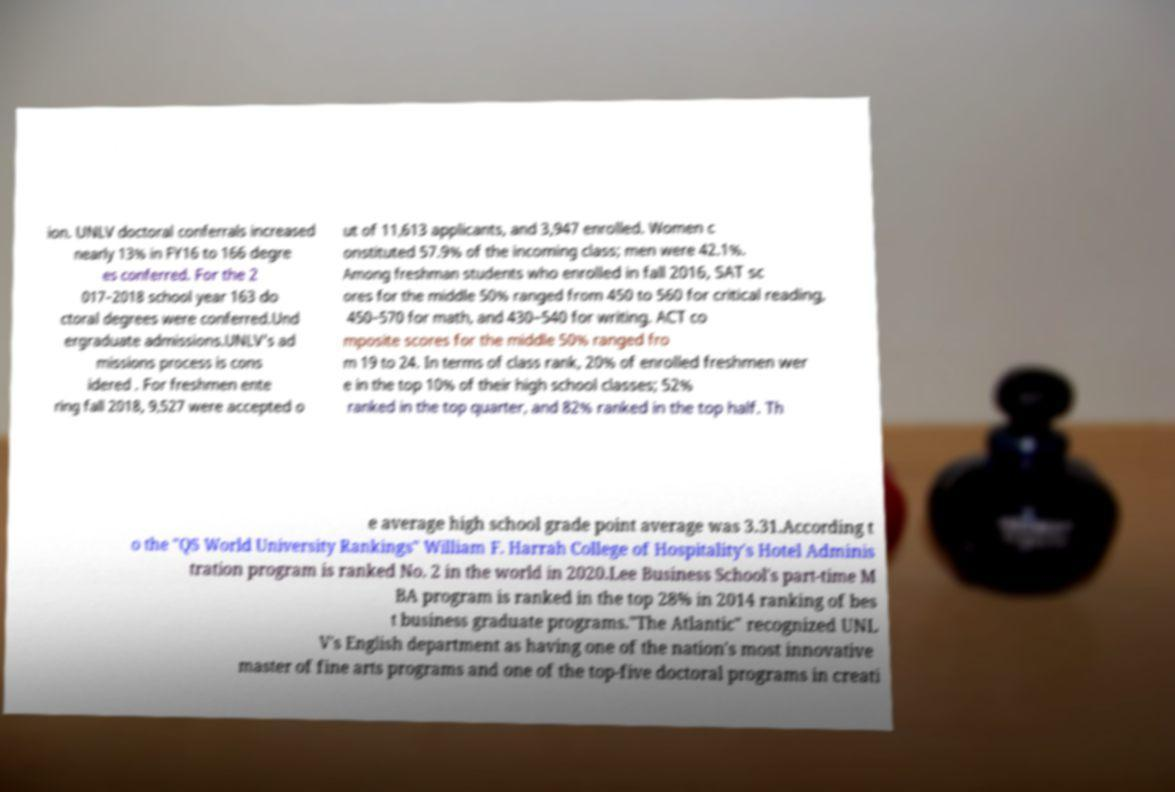For documentation purposes, I need the text within this image transcribed. Could you provide that? ion. UNLV doctoral conferrals increased nearly 13% in FY16 to 166 degre es conferred. For the 2 017–2018 school year 163 do ctoral degrees were conferred.Und ergraduate admissions.UNLV's ad missions process is cons idered . For freshmen ente ring fall 2018, 9,527 were accepted o ut of 11,613 applicants, and 3,947 enrolled. Women c onstituted 57.9% of the incoming class; men were 42.1%. Among freshman students who enrolled in fall 2016, SAT sc ores for the middle 50% ranged from 450 to 560 for critical reading, 450–570 for math, and 430–540 for writing. ACT co mposite scores for the middle 50% ranged fro m 19 to 24. In terms of class rank, 20% of enrolled freshmen wer e in the top 10% of their high school classes; 52% ranked in the top quarter, and 82% ranked in the top half. Th e average high school grade point average was 3.31.According t o the "QS World University Rankings" William F. Harrah College of Hospitality's Hotel Adminis tration program is ranked No. 2 in the world in 2020.Lee Business School's part-time M BA program is ranked in the top 28% in 2014 ranking of bes t business graduate programs."The Atlantic" recognized UNL V's English department as having one of the nation's most innovative master of fine arts programs and one of the top-five doctoral programs in creati 